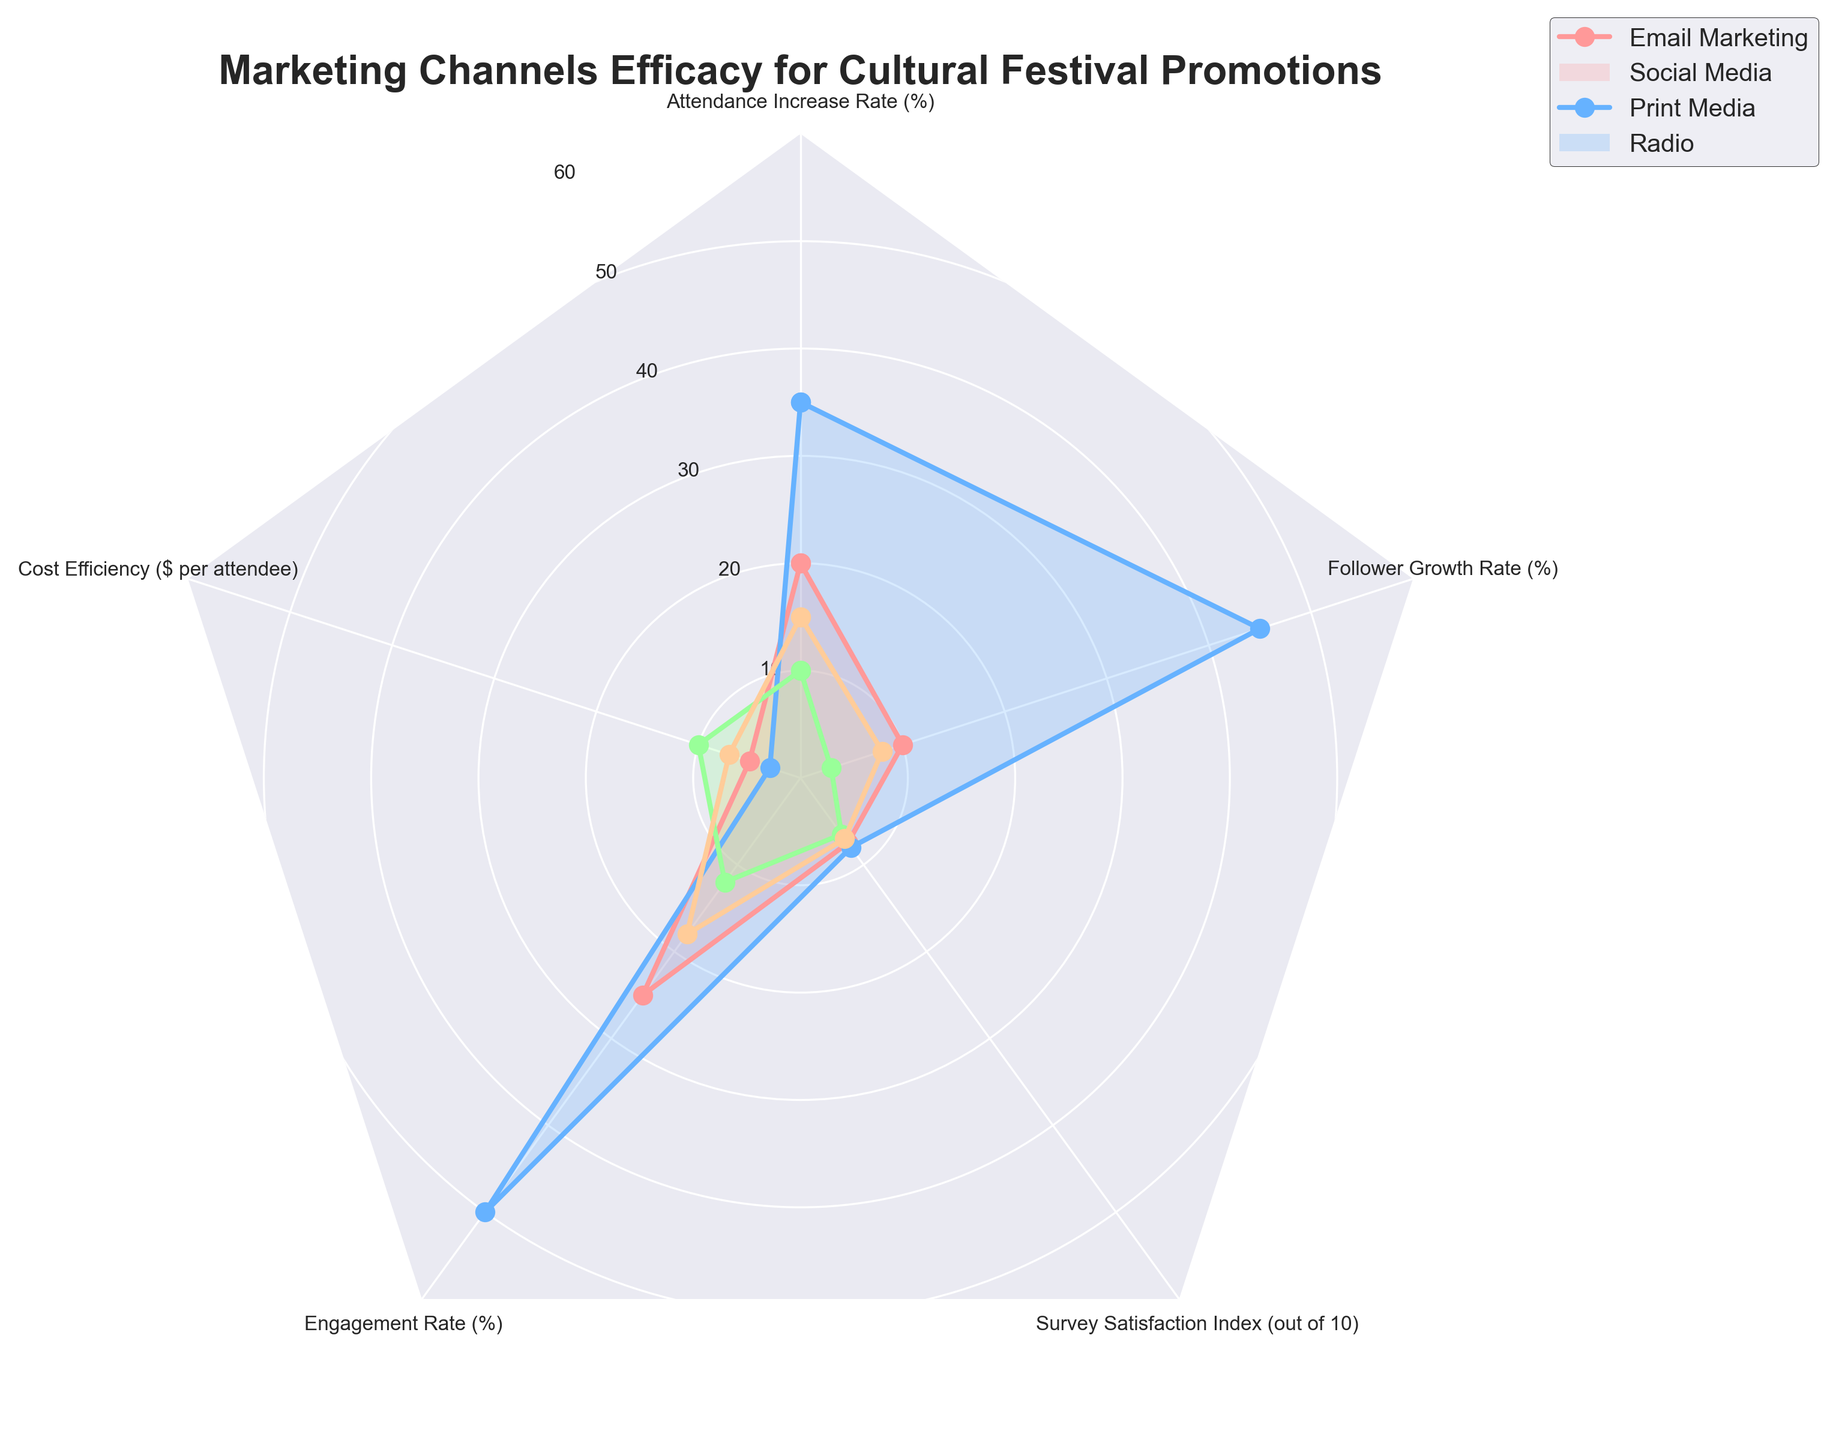What is the title of the figure? Look at the top of the radar chart where the title is usually placed.
Answer: Marketing Channels Efficacy for Cultural Festival Promotions Which marketing channel has the highest engagement rate? Refer to the engagement rate values plotted on the chart for each channel. Identify the one with the highest value.
Answer: Social Media Which marketing channel has the lowest cost efficiency? Evaluate the cost efficiency values plotted for each channel. Identify the one with the lowest value.
Answer: Social Media What is the color used to represent the Email Marketing channel? Observe the colors used in the radar chart for each channel. Determine the color representing Email Marketing.
Answer: Pink What is the average follower growth rate of all channels? Calculate the average by summing up the follower growth rates of all channels and dividing by the number of channels. (10 + 45 + 3 + 8) / 4 = 16.5.
Answer: 16.5 Which marketing channel shows the greatest increase in festival attendance? Find the attendance increase rate values for each channel and identify the one with the highest value.
Answer: Social Media How does Print Media compare to Radio in terms of survey satisfaction? Compare the survey satisfaction index values for Print Media and Radio. Print Media has 6.5, while Radio has 7.
Answer: Radio is higher Which channel exhibits the greatest discrepancy between engagement rate and follower growth rate? Calculate the difference between engagement rate and follower growth rate for each channel. The largest discrepancy is with Social Media (50 - 45 = 5).
Answer: Social Media What is the total survey satisfaction index sum for all channels? Add up the survey satisfaction index values for each channel. 7.5 + 8 + 6.5 + 7 = 29.
Answer: 29 How many variables are presented in the radar chart? Count the distinct variables listed across all marketing channels. The variables are Attendance Increase Rate, Cost Efficiency, Engagement Rate, Survey Satisfaction Index, and Follower Growth Rate.
Answer: 5 